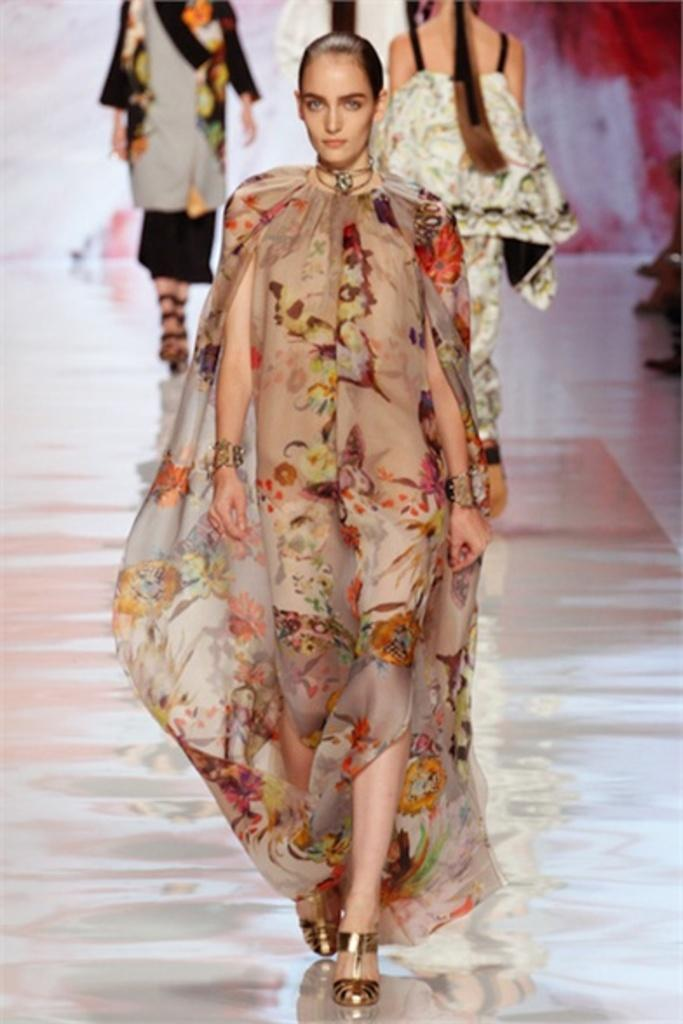What is the main subject of the image? The main subject of the image is a woman walking on a ramp. Are there any other people in the image? Yes, there are three other women behind the first woman. How many pigs are visible in the image? There are no pigs present in the image. What type of arm is being used by the woman walking on the ramp? The image does not show any specific type of arm being used by the woman; it only shows her walking on a ramp. 